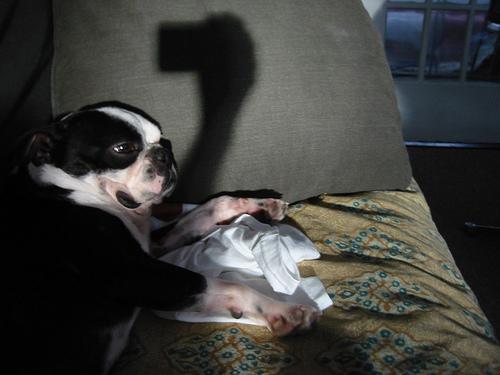Does the dog have a collar on?
Quick response, please. No. What is cast?
Quick response, please. Shadow. Is the dog awake?
Be succinct. Yes. Is this a boston terrier?
Quick response, please. Yes. 